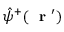<formula> <loc_0><loc_0><loc_500><loc_500>\hat { \psi } ^ { + } ( r ^ { \prime } )</formula> 